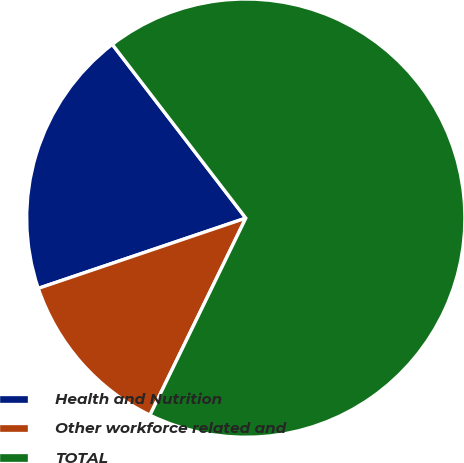<chart> <loc_0><loc_0><loc_500><loc_500><pie_chart><fcel>Health and Nutrition<fcel>Other workforce related and<fcel>TOTAL<nl><fcel>19.77%<fcel>12.6%<fcel>67.64%<nl></chart> 